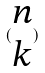<formula> <loc_0><loc_0><loc_500><loc_500>( \begin{matrix} n \\ k \end{matrix} )</formula> 